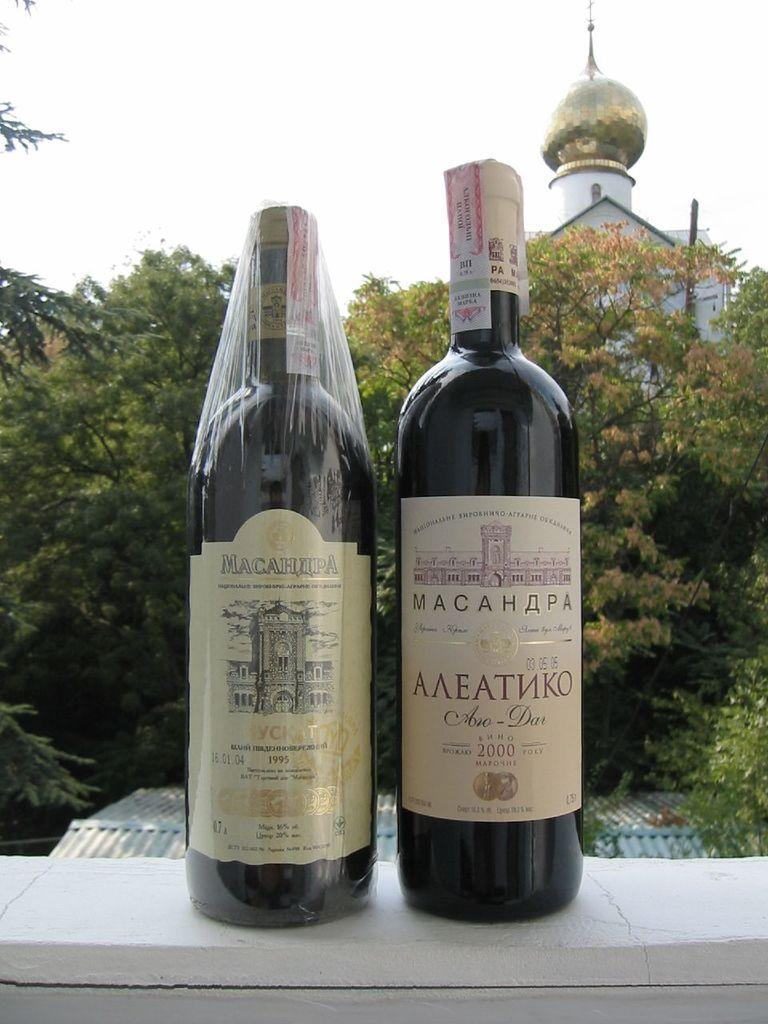<image>
Provide a brief description of the given image. The label on a bottle has the year 2000 and is next to another bottle. 